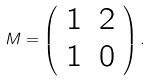<formula> <loc_0><loc_0><loc_500><loc_500>M = \left ( \begin{array} { c c } 1 & 2 \\ 1 & 0 \end{array} \right ) .</formula> 